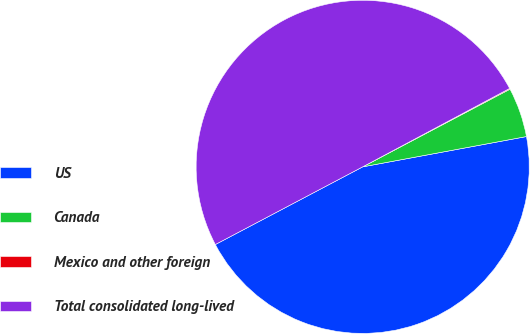Convert chart. <chart><loc_0><loc_0><loc_500><loc_500><pie_chart><fcel>US<fcel>Canada<fcel>Mexico and other foreign<fcel>Total consolidated long-lived<nl><fcel>45.19%<fcel>4.81%<fcel>0.08%<fcel>49.92%<nl></chart> 